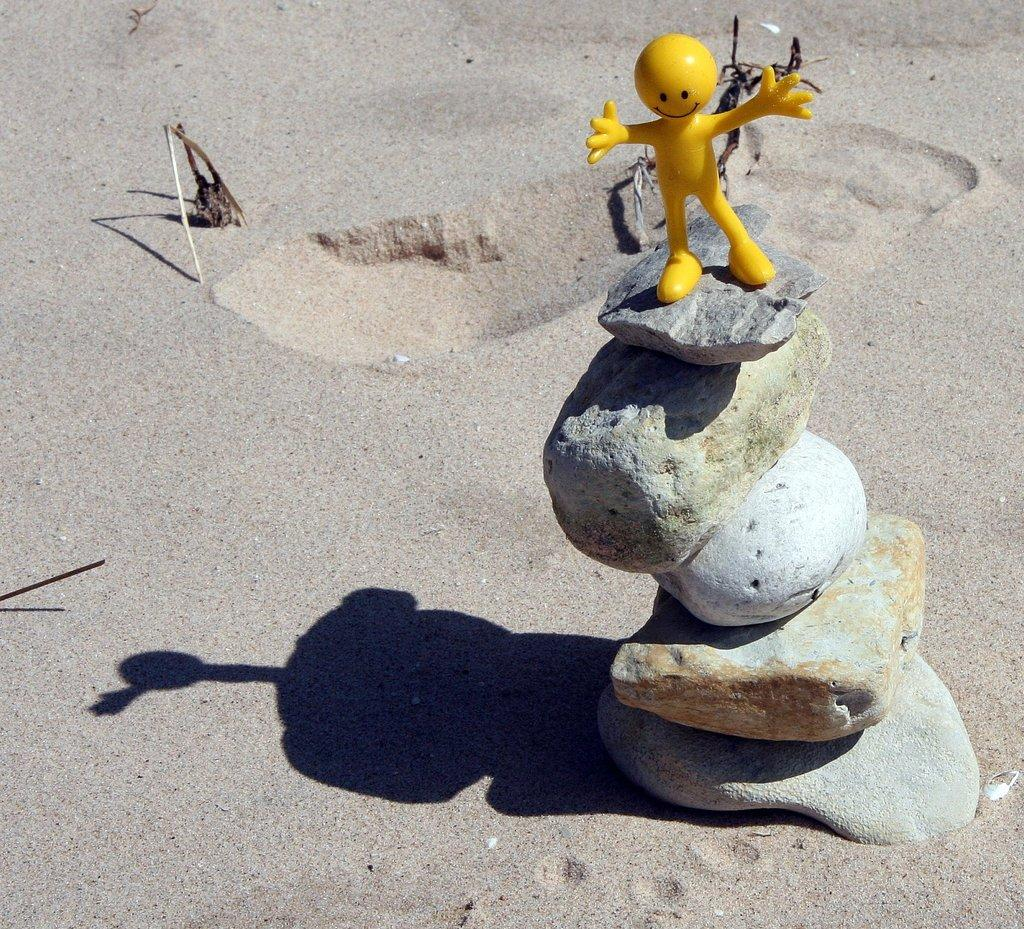What type of objects can be seen in the image? There are stones and a yellow toy in the image. What is the texture or material of the ground in the image? There is sand in the image. What is the cause of death in the image? There is no indication of death or any living beings in the image. 